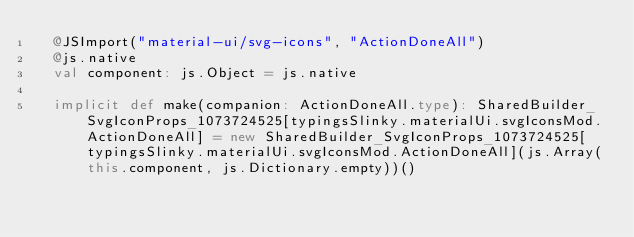<code> <loc_0><loc_0><loc_500><loc_500><_Scala_>  @JSImport("material-ui/svg-icons", "ActionDoneAll")
  @js.native
  val component: js.Object = js.native
  
  implicit def make(companion: ActionDoneAll.type): SharedBuilder_SvgIconProps_1073724525[typingsSlinky.materialUi.svgIconsMod.ActionDoneAll] = new SharedBuilder_SvgIconProps_1073724525[typingsSlinky.materialUi.svgIconsMod.ActionDoneAll](js.Array(this.component, js.Dictionary.empty))()
  </code> 